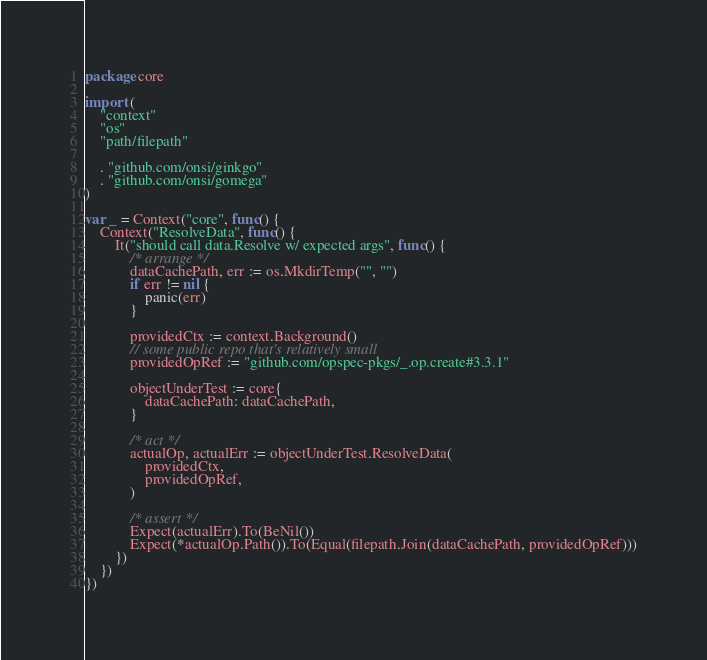Convert code to text. <code><loc_0><loc_0><loc_500><loc_500><_Go_>package core

import (
	"context"
	"os"
	"path/filepath"

	. "github.com/onsi/ginkgo"
	. "github.com/onsi/gomega"
)

var _ = Context("core", func() {
	Context("ResolveData", func() {
		It("should call data.Resolve w/ expected args", func() {
			/* arrange */
			dataCachePath, err := os.MkdirTemp("", "")
			if err != nil {
				panic(err)
			}

			providedCtx := context.Background()
			// some public repo that's relatively small
			providedOpRef := "github.com/opspec-pkgs/_.op.create#3.3.1"

			objectUnderTest := core{
				dataCachePath: dataCachePath,
			}

			/* act */
			actualOp, actualErr := objectUnderTest.ResolveData(
				providedCtx,
				providedOpRef,
			)

			/* assert */
			Expect(actualErr).To(BeNil())
			Expect(*actualOp.Path()).To(Equal(filepath.Join(dataCachePath, providedOpRef)))
		})
	})
})
</code> 